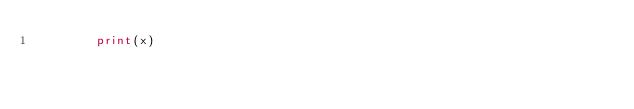<code> <loc_0><loc_0><loc_500><loc_500><_Python_>        print(x)
</code> 